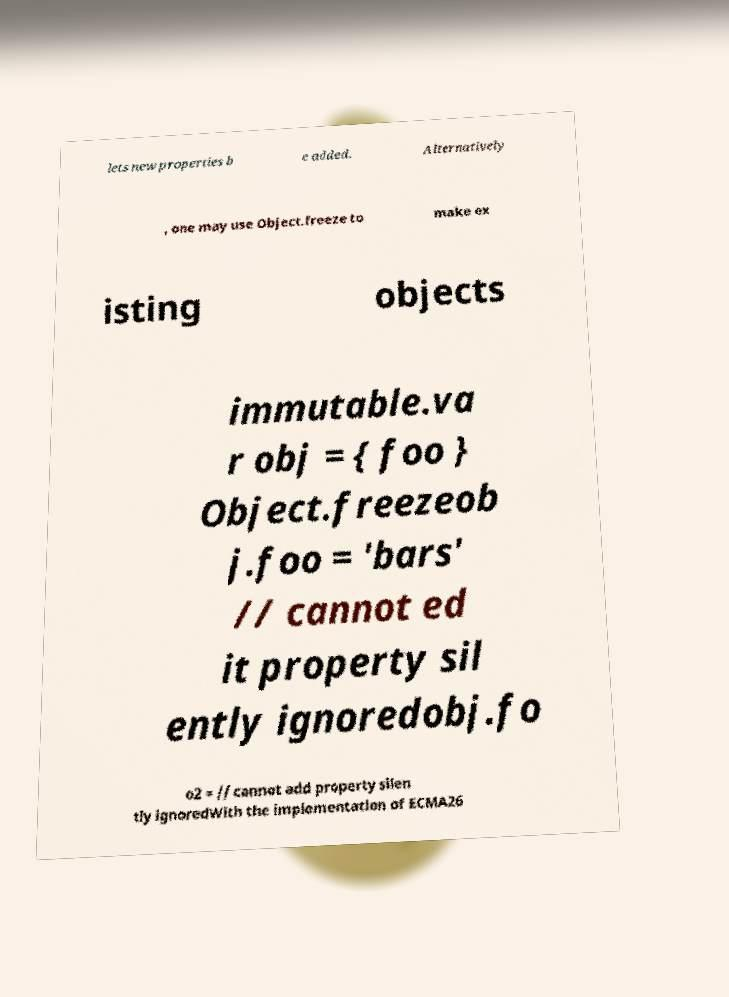There's text embedded in this image that I need extracted. Can you transcribe it verbatim? lets new properties b e added. Alternatively , one may use Object.freeze to make ex isting objects immutable.va r obj = { foo } Object.freezeob j.foo = 'bars' // cannot ed it property sil ently ignoredobj.fo o2 = // cannot add property silen tly ignoredWith the implementation of ECMA26 